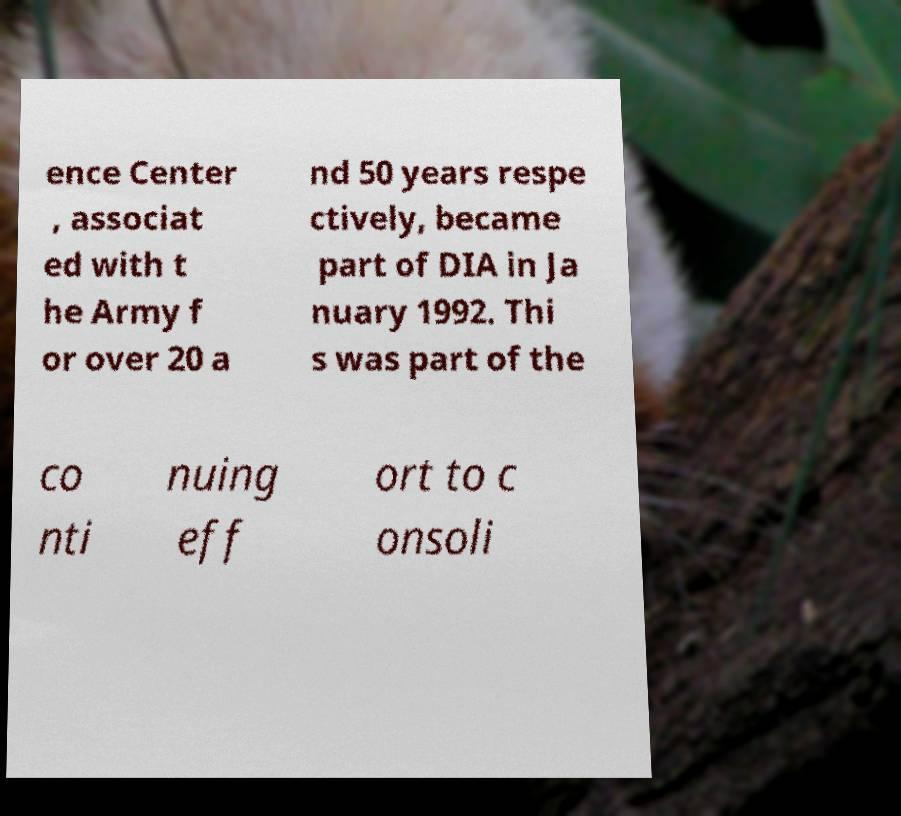Can you read and provide the text displayed in the image?This photo seems to have some interesting text. Can you extract and type it out for me? ence Center , associat ed with t he Army f or over 20 a nd 50 years respe ctively, became part of DIA in Ja nuary 1992. Thi s was part of the co nti nuing eff ort to c onsoli 